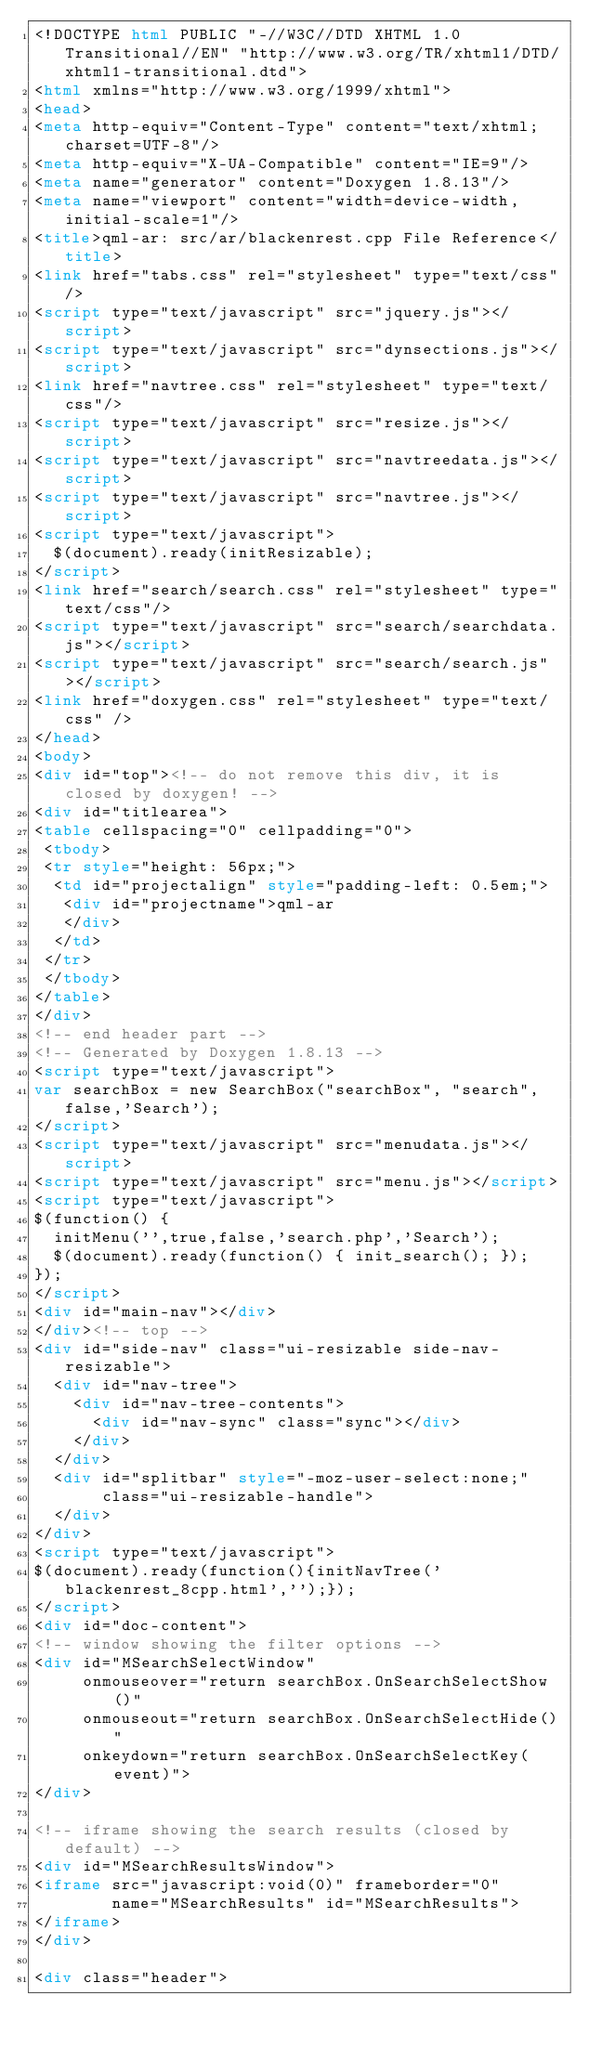<code> <loc_0><loc_0><loc_500><loc_500><_HTML_><!DOCTYPE html PUBLIC "-//W3C//DTD XHTML 1.0 Transitional//EN" "http://www.w3.org/TR/xhtml1/DTD/xhtml1-transitional.dtd">
<html xmlns="http://www.w3.org/1999/xhtml">
<head>
<meta http-equiv="Content-Type" content="text/xhtml;charset=UTF-8"/>
<meta http-equiv="X-UA-Compatible" content="IE=9"/>
<meta name="generator" content="Doxygen 1.8.13"/>
<meta name="viewport" content="width=device-width, initial-scale=1"/>
<title>qml-ar: src/ar/blackenrest.cpp File Reference</title>
<link href="tabs.css" rel="stylesheet" type="text/css"/>
<script type="text/javascript" src="jquery.js"></script>
<script type="text/javascript" src="dynsections.js"></script>
<link href="navtree.css" rel="stylesheet" type="text/css"/>
<script type="text/javascript" src="resize.js"></script>
<script type="text/javascript" src="navtreedata.js"></script>
<script type="text/javascript" src="navtree.js"></script>
<script type="text/javascript">
  $(document).ready(initResizable);
</script>
<link href="search/search.css" rel="stylesheet" type="text/css"/>
<script type="text/javascript" src="search/searchdata.js"></script>
<script type="text/javascript" src="search/search.js"></script>
<link href="doxygen.css" rel="stylesheet" type="text/css" />
</head>
<body>
<div id="top"><!-- do not remove this div, it is closed by doxygen! -->
<div id="titlearea">
<table cellspacing="0" cellpadding="0">
 <tbody>
 <tr style="height: 56px;">
  <td id="projectalign" style="padding-left: 0.5em;">
   <div id="projectname">qml-ar
   </div>
  </td>
 </tr>
 </tbody>
</table>
</div>
<!-- end header part -->
<!-- Generated by Doxygen 1.8.13 -->
<script type="text/javascript">
var searchBox = new SearchBox("searchBox", "search",false,'Search');
</script>
<script type="text/javascript" src="menudata.js"></script>
<script type="text/javascript" src="menu.js"></script>
<script type="text/javascript">
$(function() {
  initMenu('',true,false,'search.php','Search');
  $(document).ready(function() { init_search(); });
});
</script>
<div id="main-nav"></div>
</div><!-- top -->
<div id="side-nav" class="ui-resizable side-nav-resizable">
  <div id="nav-tree">
    <div id="nav-tree-contents">
      <div id="nav-sync" class="sync"></div>
    </div>
  </div>
  <div id="splitbar" style="-moz-user-select:none;" 
       class="ui-resizable-handle">
  </div>
</div>
<script type="text/javascript">
$(document).ready(function(){initNavTree('blackenrest_8cpp.html','');});
</script>
<div id="doc-content">
<!-- window showing the filter options -->
<div id="MSearchSelectWindow"
     onmouseover="return searchBox.OnSearchSelectShow()"
     onmouseout="return searchBox.OnSearchSelectHide()"
     onkeydown="return searchBox.OnSearchSelectKey(event)">
</div>

<!-- iframe showing the search results (closed by default) -->
<div id="MSearchResultsWindow">
<iframe src="javascript:void(0)" frameborder="0" 
        name="MSearchResults" id="MSearchResults">
</iframe>
</div>

<div class="header"></code> 